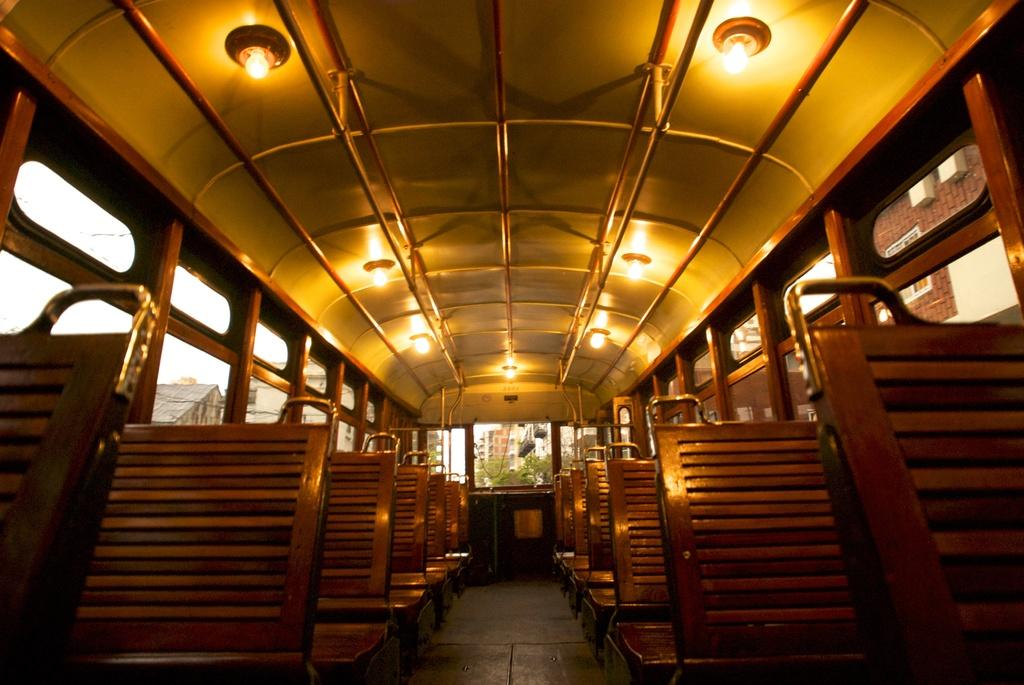What type of space is shown in the image? The image is an inside view of a vehicle. What type of seating is available in the vehicle? There are benches in the vehicle. What can be seen on the ceiling of the vehicle? There are lights on the ceiling of the vehicle. What allows natural light to enter the vehicle? There are windows in the vehicle. What can be seen outside the vehicle through the windows? Trees, buildings, and the sky are visible through the windows. Are there any plants growing inside the vehicle in the image? No, there are no plants visible inside the vehicle in the image. Is there a bag hanging from the ceiling of the vehicle in the image? No, there is no bag hanging from the ceiling of the vehicle in the image. 